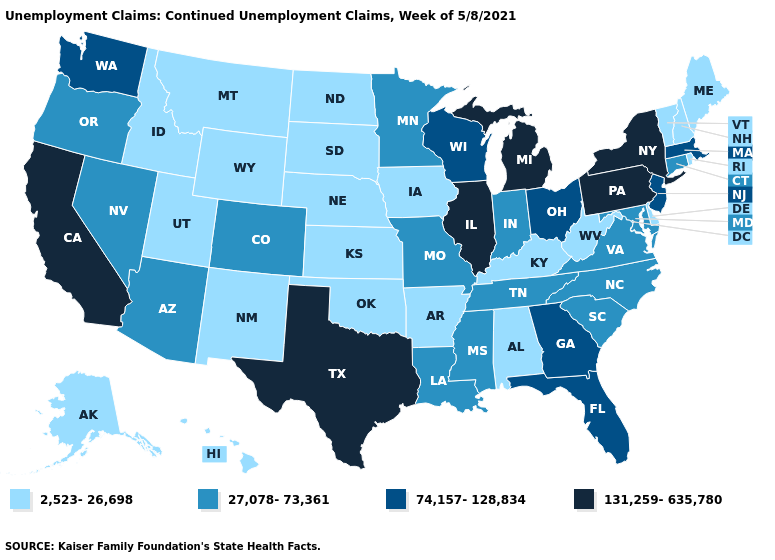Among the states that border New Mexico , which have the highest value?
Quick response, please. Texas. What is the highest value in the USA?
Answer briefly. 131,259-635,780. Does Missouri have the highest value in the USA?
Quick response, please. No. What is the value of Missouri?
Answer briefly. 27,078-73,361. Does West Virginia have the same value as Ohio?
Give a very brief answer. No. Does Montana have the lowest value in the West?
Be succinct. Yes. What is the value of West Virginia?
Write a very short answer. 2,523-26,698. Which states have the lowest value in the West?
Be succinct. Alaska, Hawaii, Idaho, Montana, New Mexico, Utah, Wyoming. Name the states that have a value in the range 27,078-73,361?
Write a very short answer. Arizona, Colorado, Connecticut, Indiana, Louisiana, Maryland, Minnesota, Mississippi, Missouri, Nevada, North Carolina, Oregon, South Carolina, Tennessee, Virginia. What is the highest value in states that border Georgia?
Short answer required. 74,157-128,834. Is the legend a continuous bar?
Quick response, please. No. What is the highest value in the USA?
Answer briefly. 131,259-635,780. What is the value of Massachusetts?
Answer briefly. 74,157-128,834. Does Massachusetts have the lowest value in the Northeast?
Give a very brief answer. No. 